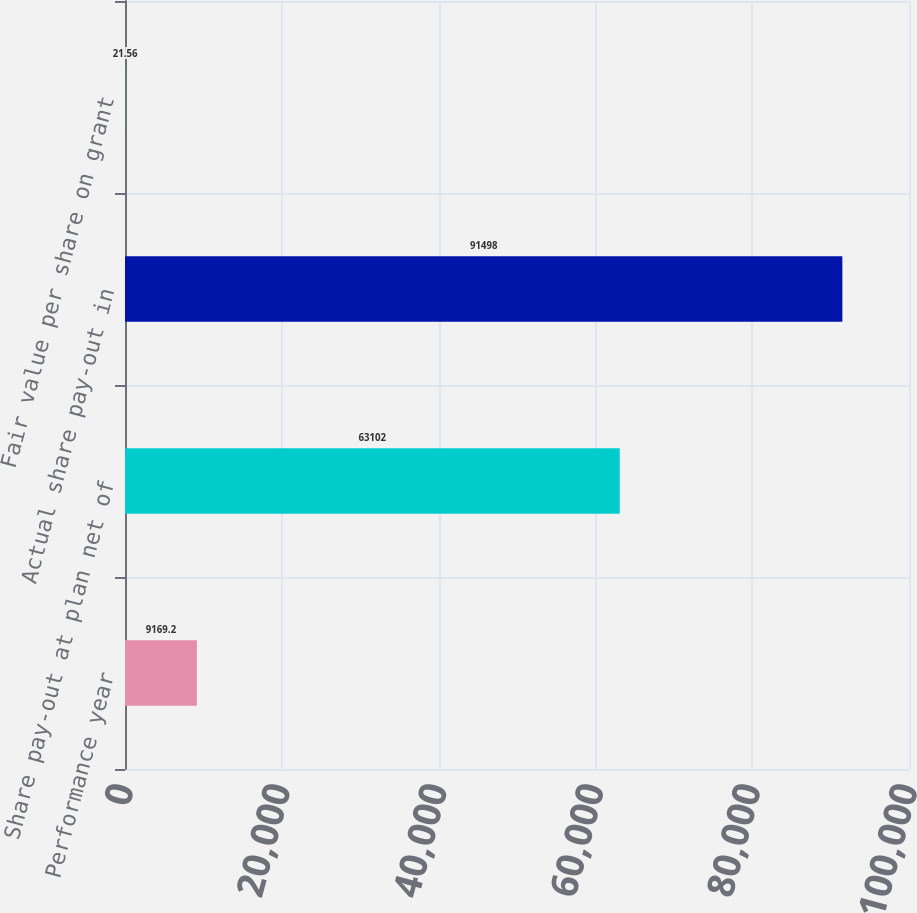Convert chart. <chart><loc_0><loc_0><loc_500><loc_500><bar_chart><fcel>Performance year<fcel>Share pay-out at plan net of<fcel>Actual share pay-out in<fcel>Fair value per share on grant<nl><fcel>9169.2<fcel>63102<fcel>91498<fcel>21.56<nl></chart> 